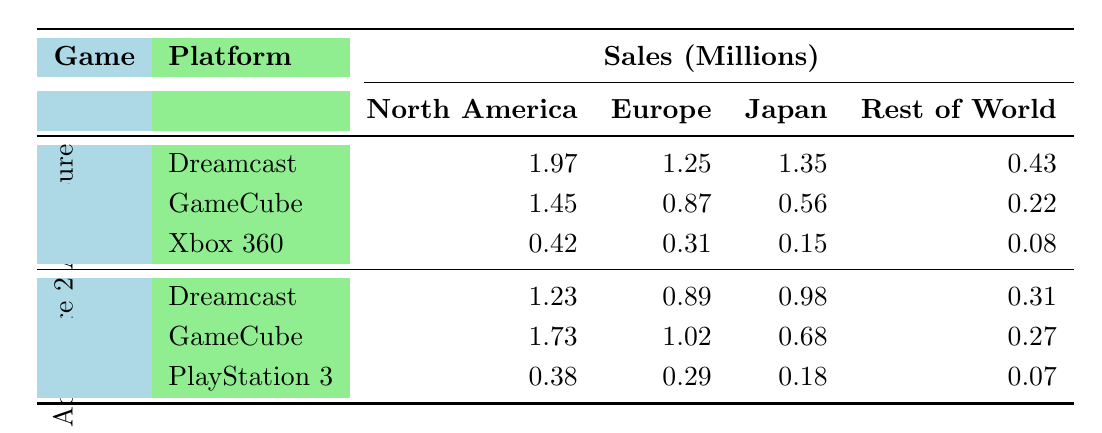What are the total sales of "Sonic Adventure" on Dreamcast across all regions? The sales figures for "Sonic Adventure" on Dreamcast are: North America (1.97), Europe (1.25), Japan (1.35), Rest of World (0.43). Adding these gives: 1.97 + 1.25 + 1.35 + 0.43 = 5.00 million.
Answer: 5.00 million Which game had the highest sales in Japan? Looking at the Japan sales figures, "Sonic Adventure" on Dreamcast sold 1.35, "Sonic Adventure 2" on Dreamcast sold 0.98, and "Sonic Adventure 2: Battle" on GameCube sold 0.68. The highest sales figure is 1.35 from "Sonic Adventure" on Dreamcast.
Answer: Sonic Adventure What is the difference in sales between "Sonic Adventure 2: Battle" and "Sonic Adventure DX: Director's Cut" in North America? The North American sales for "Sonic Adventure 2: Battle" are 1.73 million, while for "Sonic Adventure DX: Director's Cut" they are 1.45 million. The difference is calculated as 1.73 - 1.45 = 0.28 million.
Answer: 0.28 million What is the average sales figure for "Sonic Adventure 2" across all platforms and regions? The sales figures for "Sonic Adventure 2" are: Dreamcast (1.23 + 0.89 + 0.98 + 0.31 = 3.41), GameCube (1.73 + 1.02 + 0.68 + 0.27 = 3.70), and PlayStation 3 (0.38 + 0.29 + 0.18 + 0.07 = 0.92). Summing these gives total sales of 3.41 + 3.70 + 0.92 = 8.03 million across 3 platforms, so the average is 8.03 / 3 = 2.68 million.
Answer: 2.68 million Which platform had the lowest sales for "Sonic Adventure"? Analyzing the sales for "Sonic Adventure," Xbox 360 has sales figures of 0.42 in North America, 0.31 in Europe, 0.15 in Japan, and 0.08 in Rest of World, totaling 1.96 million. This is less than the totals for Dreamcast (5.00 million) and GameCube (2.10 million).
Answer: Xbox 360 Based on the data, did "Sonic Adventure 2: Battle" outsell "Sonic Adventure 2" on any platform? Comparing the sales figures, "Sonic Adventure 2: Battle" on GameCube (1.73) outsold "Sonic Adventure 2" on Dreamcast (1.23), and also its combined sales from Europe (1.02) and Japan (0.68) where it has higher sales (1.73) across the board on this platform. Overall, "Sonic Adventure 2: Battle" performed better than "Sonic Adventure 2".
Answer: Yes What is the total sales of "Sonic Adventure DX: Director's Cut" in Europe? The sales for "Sonic Adventure DX: Director's Cut" in Europe is explicitly listed as 0.87 million.
Answer: 0.87 million How many million copies of the Sonic Adventure Series were sold in total across all regions? By summing sales across all games and regions: "Sonic Adventure" (5.00) + "Sonic Adventure 2" (3.41) + "Sonic Adventure DX: Director's Cut" (2.10) + "Sonic Adventure 2: Battle" (3.70) + "Sonic Adventure" on Xbox 360 (1.96) + "Sonic Adventure 2" on PlayStation 3 (0.92), the total equals 17.09 million copies sold.
Answer: 17.09 million 